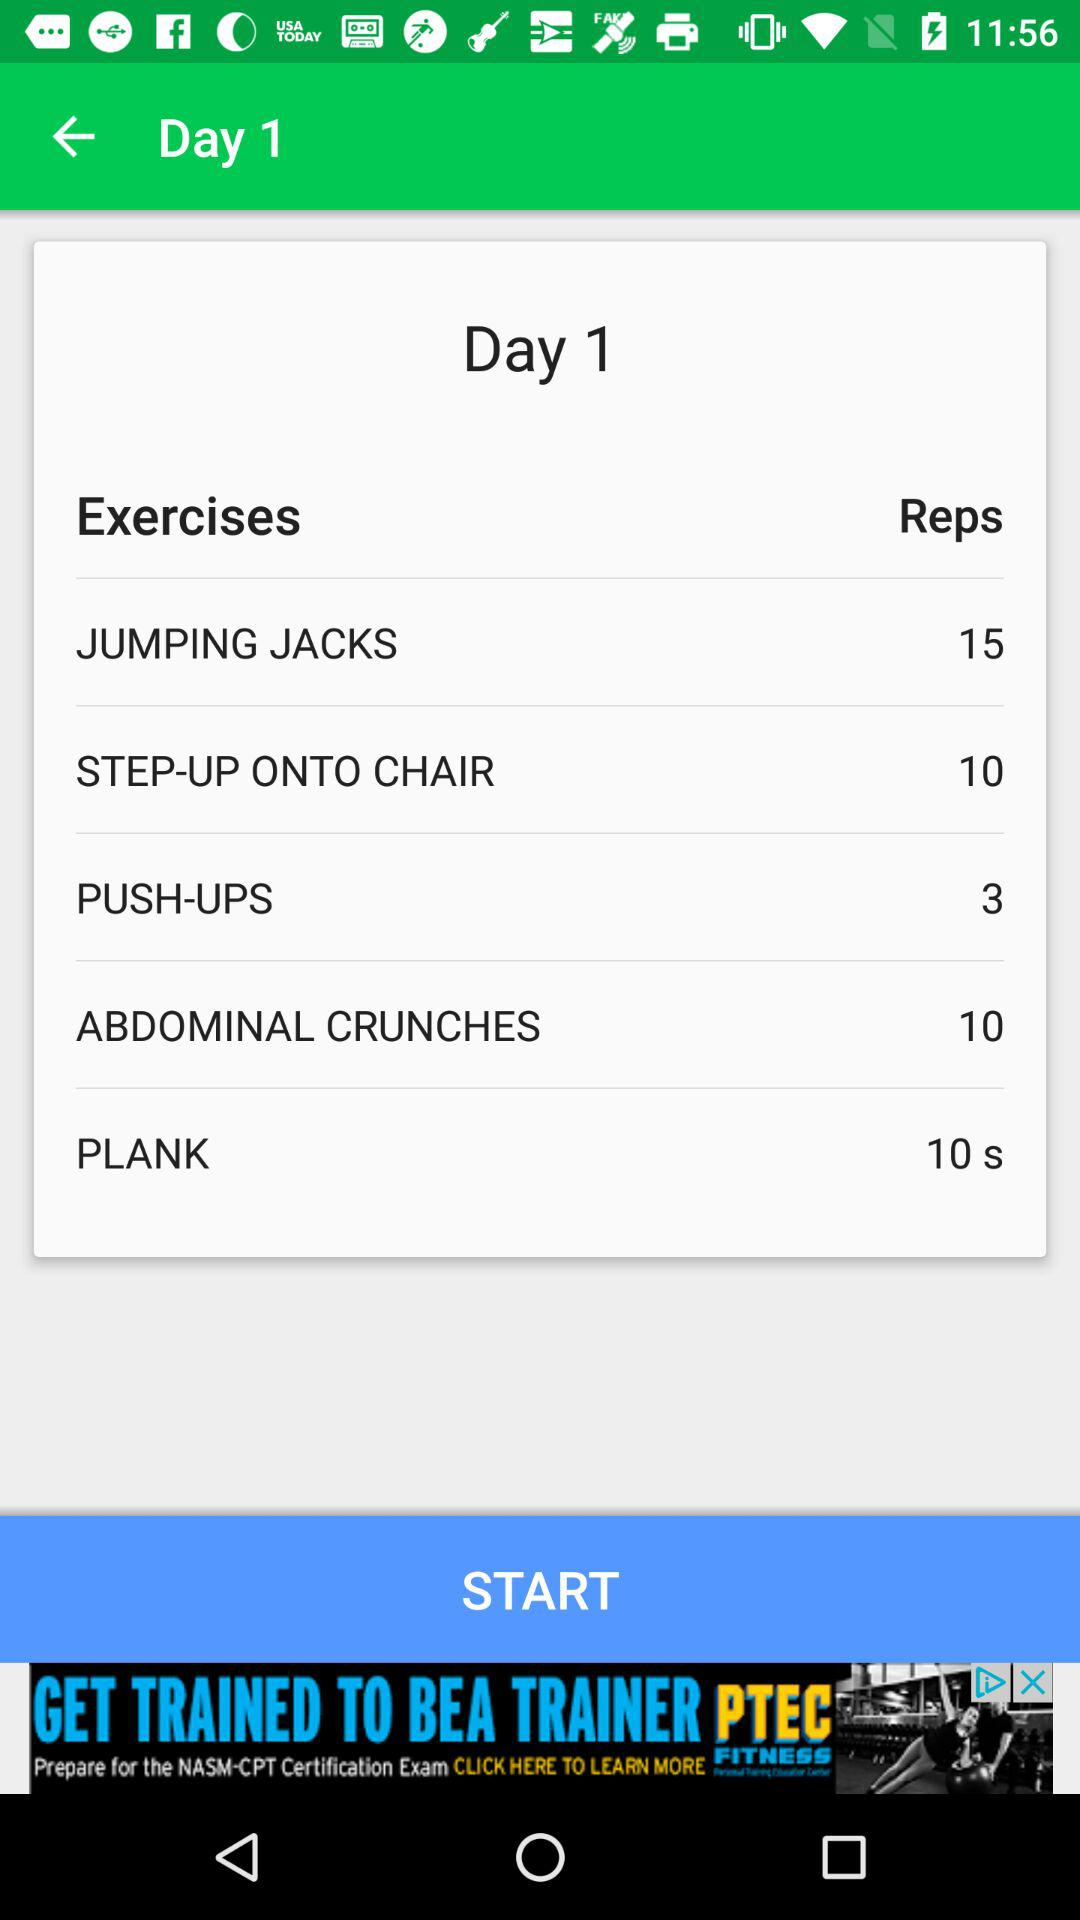For which exercise are 15 reps being shown? 15 reps are being shown for jumping jacks. 